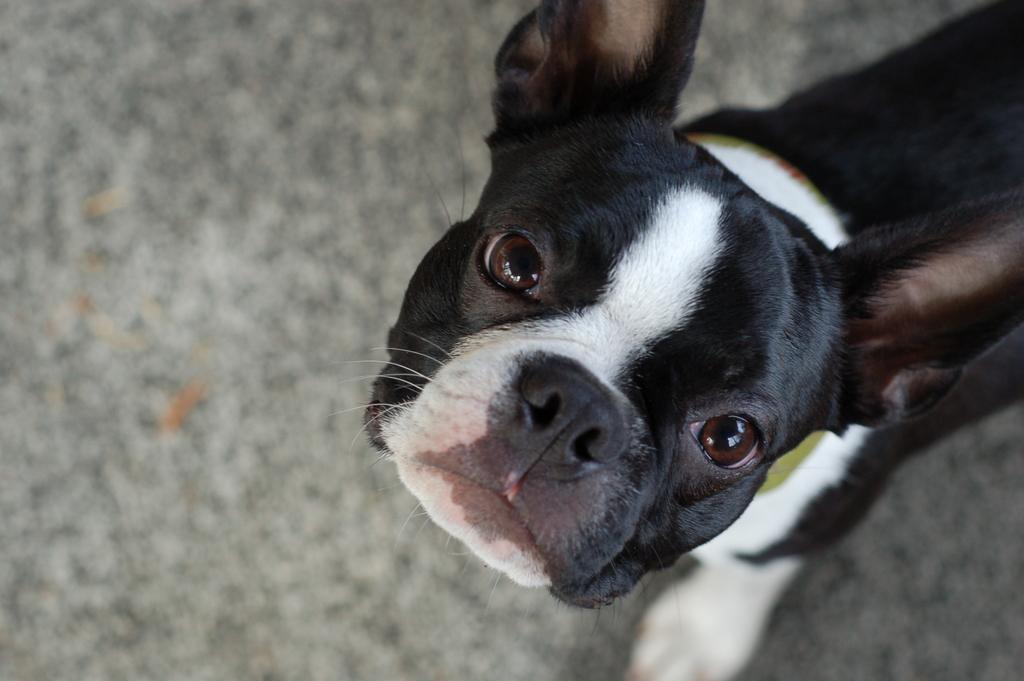What type of animal is in the image? There is a dog in the image. What colors can be seen on the dog? The dog has white, black, and brown colors. What is the dog standing on? The dog is standing on a surface. What color is the surface the dog is standing on? The surface has an ash color. What emotions does the dog display during the feast in the image? There is no feast or emotions displayed by the dog in the image; it is simply a dog standing on an ash-colored surface. 